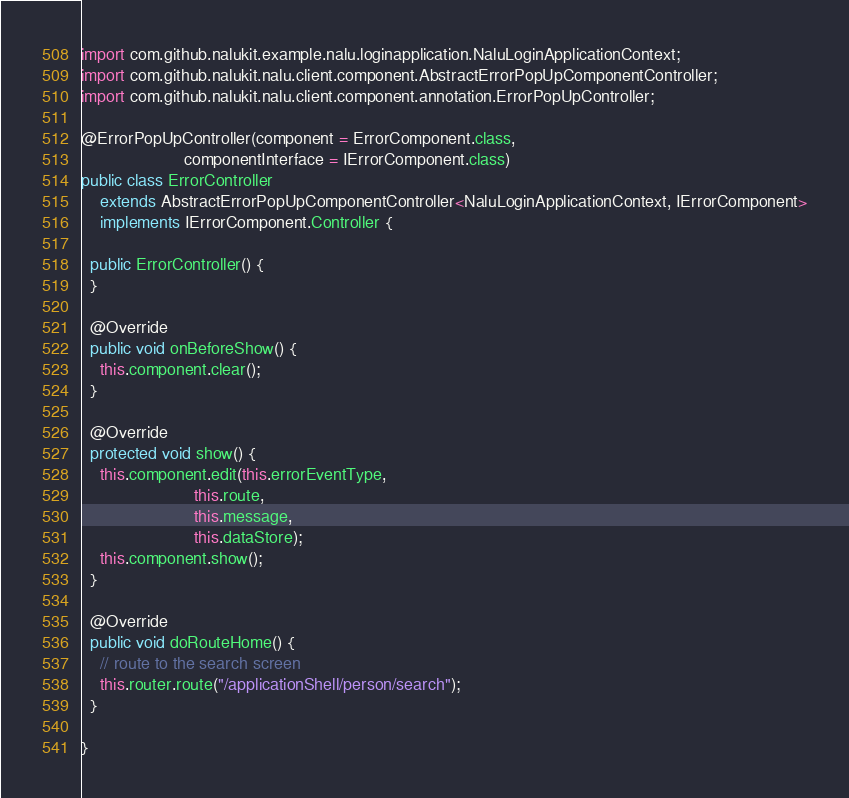Convert code to text. <code><loc_0><loc_0><loc_500><loc_500><_Java_>import com.github.nalukit.example.nalu.loginapplication.NaluLoginApplicationContext;
import com.github.nalukit.nalu.client.component.AbstractErrorPopUpComponentController;
import com.github.nalukit.nalu.client.component.annotation.ErrorPopUpController;

@ErrorPopUpController(component = ErrorComponent.class,
                      componentInterface = IErrorComponent.class)
public class ErrorController
    extends AbstractErrorPopUpComponentController<NaluLoginApplicationContext, IErrorComponent>
    implements IErrorComponent.Controller {

  public ErrorController() {
  }

  @Override
  public void onBeforeShow() {
    this.component.clear();
  }

  @Override
  protected void show() {
    this.component.edit(this.errorEventType,
                        this.route,
                        this.message,
                        this.dataStore);
    this.component.show();
  }

  @Override
  public void doRouteHome() {
    // route to the search screen
    this.router.route("/applicationShell/person/search");
  }

}
</code> 